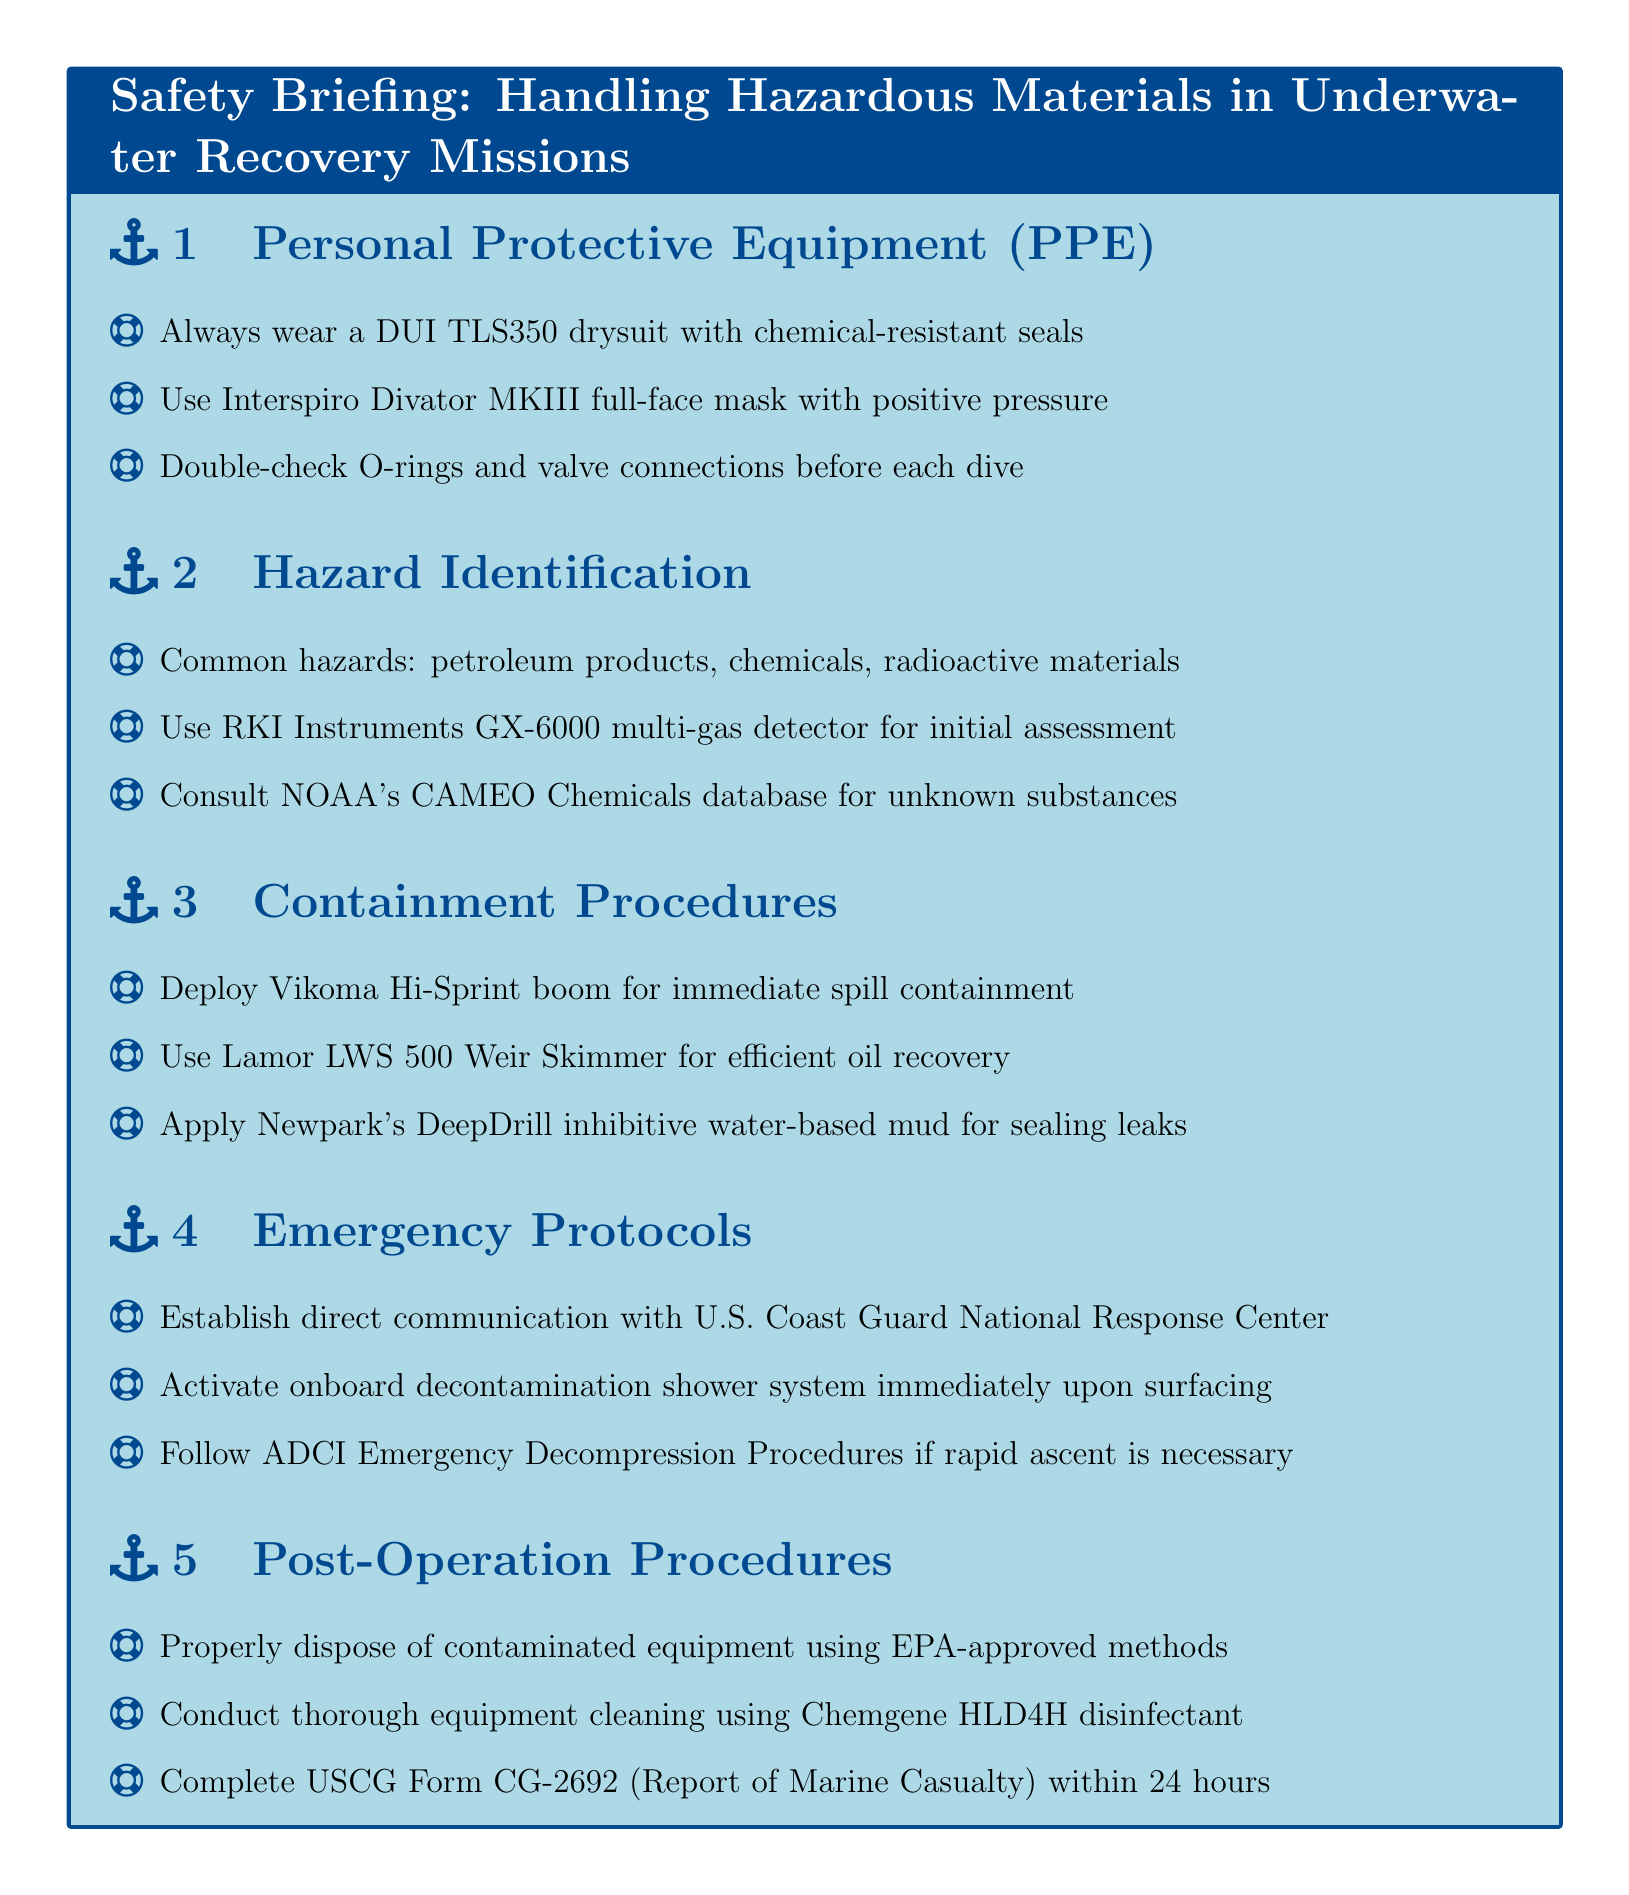what is the name of the drysuit to wear? The document specifies to always wear a DUI TLS350 drysuit with chemical-resistant seals.
Answer: DUI TLS350 what equipment is used for initial hazard assessment? The document states to use RKI Instruments GX-6000 multi-gas detector for initial assessment.
Answer: RKI Instruments GX-6000 what is applied for sealing leaks? According to the document, Newpark's DeepDrill inhibitive water-based mud is applied for sealing leaks.
Answer: Newpark's DeepDrill who should you communicate with during an emergency? The document mentions to establish direct communication with the U.S. Coast Guard National Response Center during emergencies.
Answer: U.S. Coast Guard National Response Center what disinfectant is recommended for cleaning equipment? The document recommends using Chemgene HLD4H disinfectant for thorough equipment cleaning.
Answer: Chemgene HLD4H how long do you have to complete the USCG Form CG-2692? The notes specify to complete the USCG Form CG-2692 within 24 hours.
Answer: 24 hours what type of mask should be used? The document specifies using an Interspiro Divator MKIII full-face mask with positive pressure.
Answer: Interspiro Divator MKIII which boom is deployed for spill containment? The document states to deploy the Vikoma Hi-Sprint boom for immediate spill containment.
Answer: Vikoma Hi-Sprint boom what type of mask provides positive pressure? The document indicates that the Interspiro Divator MKIII full-face mask provides positive pressure.
Answer: Interspiro Divator MKIII 